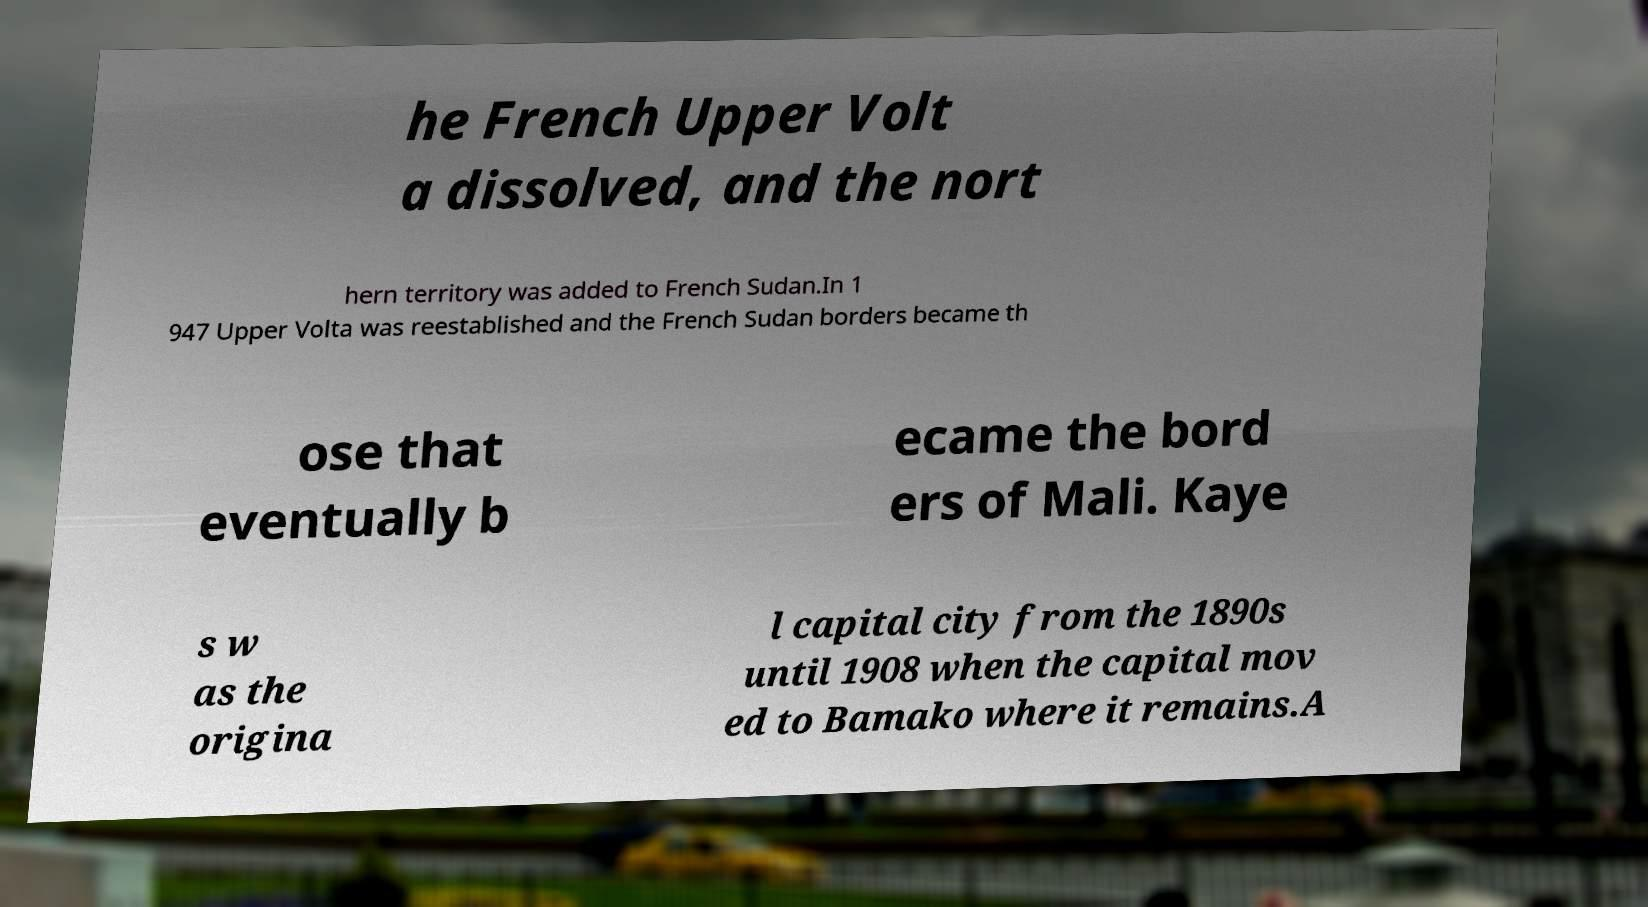Can you read and provide the text displayed in the image?This photo seems to have some interesting text. Can you extract and type it out for me? he French Upper Volt a dissolved, and the nort hern territory was added to French Sudan.In 1 947 Upper Volta was reestablished and the French Sudan borders became th ose that eventually b ecame the bord ers of Mali. Kaye s w as the origina l capital city from the 1890s until 1908 when the capital mov ed to Bamako where it remains.A 